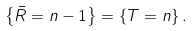<formula> <loc_0><loc_0><loc_500><loc_500>\text {\ \ } \left \{ \bar { R } = n - 1 \right \} = \left \{ T = n \right \} .</formula> 